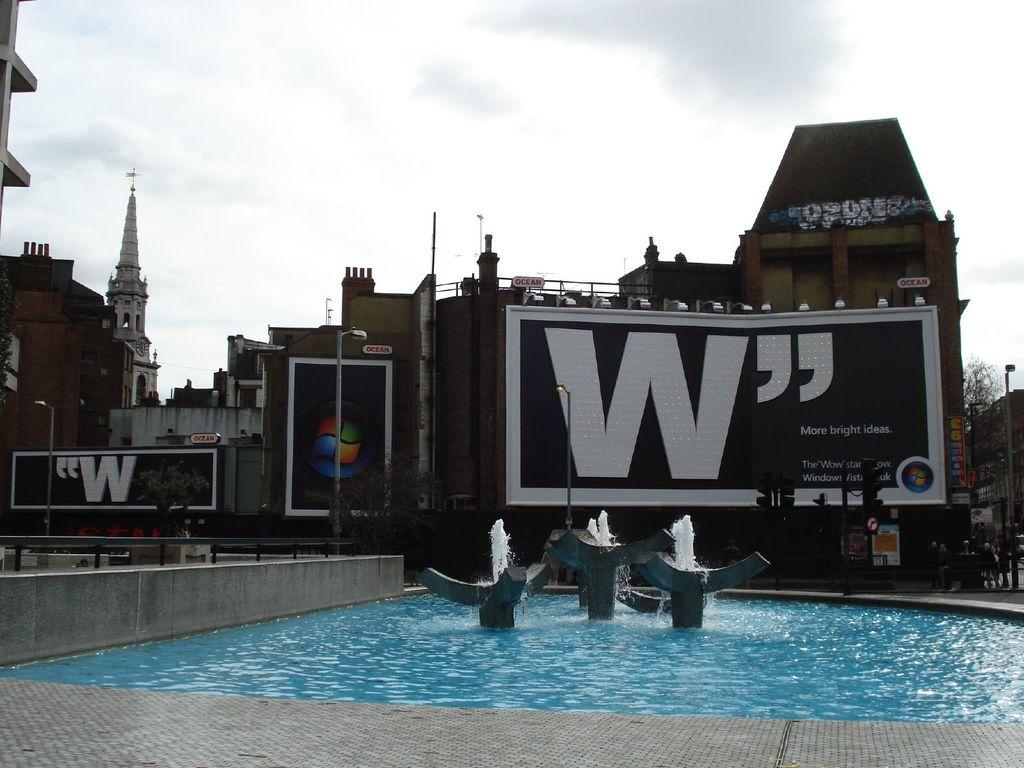What type of structures can be seen in the image? There are buildings in the image. What helps regulate traffic in the image? There are traffic signals in the image. What natural element is visible in the image? There is water visible in the image. What type of water feature is present in the image? There is a fountain in the image. What supports streetlights or signs in the image? There are street poles in the image. Are there any living beings present in the image? Yes, there are people in the image. What type of transportation can be seen in the image? There are vehicles in the image. What part of the environment is visible in the image? The sky is visible in the image. What atmospheric feature can be seen in the sky? There are clouds in the image. What type of mountain is visible in the image? There is no mountain present in the image. What type of lunch is being prepared on the stove in the image? There is no stove or lunch preparation present in the image. 